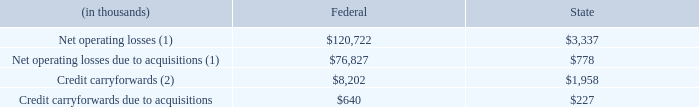At December 31, 2019, the Company’s net operating losses and credit carryforwards are:
(1) Excludes federal and state net operating losses of $60.2 million and $0.8 million, respectively, from prior acquisitions that the Company expects will expire unutilized
(2) Excludes federal and state tax credits of $0.1 million and $8.3 million, respectively, that the Company expects will expire unutilized
Carryforward losses and credits expire between 2020 and 2038, except for the 2019 federal net operating loss of $43.9 million and $1 million of state credits, which both have unlimited carryforward periods.
The Company’s India subsidiary is primarily located in Special Economic Zones (“SEZs”) and is entitled to a tax holiday in India. The tax holiday reduces or eliminates income tax in India. The tax holiday in the Hyderabad SEZ is scheduled to expire in 2024. The tax holiday in the Bangalore SEZ is scheduled to expire in 2022. For 2019, 2018 and 2017, the income tax holiday reduced the Company’s provision for income taxes by $1.9 million, $1.3 million, and $1 million, respectively.
What is excluded from the company's net operating losses calculations?  Federal and state net operating losses of $60.2 million and $0.8 million, respectively, from prior acquisitions that the company expects will expire unutilized. What is excluded from the company's credit carryforward calculations?  Federal and state tax credits of $0.1 million and $8.3 million, respectively, that the company expects will expire unutilized. What is the company's reduction in provision for income taxes arising from its income tax holiday in 2019 and 2018 respectively? $1.9 million, $1.3 million. What is the difference between the company's federal and state net operating losses?
Answer scale should be: thousand. 120,722 - 3,337 
Answer: 117385. What is the total federal and state credit carryforwards?
Answer scale should be: thousand. 1,958 + 8,202 
Answer: 10160. What is the average federal and state credit carryforwards due to acquisitions?
Answer scale should be: thousand. (640 + 227)/2 
Answer: 433.5. 